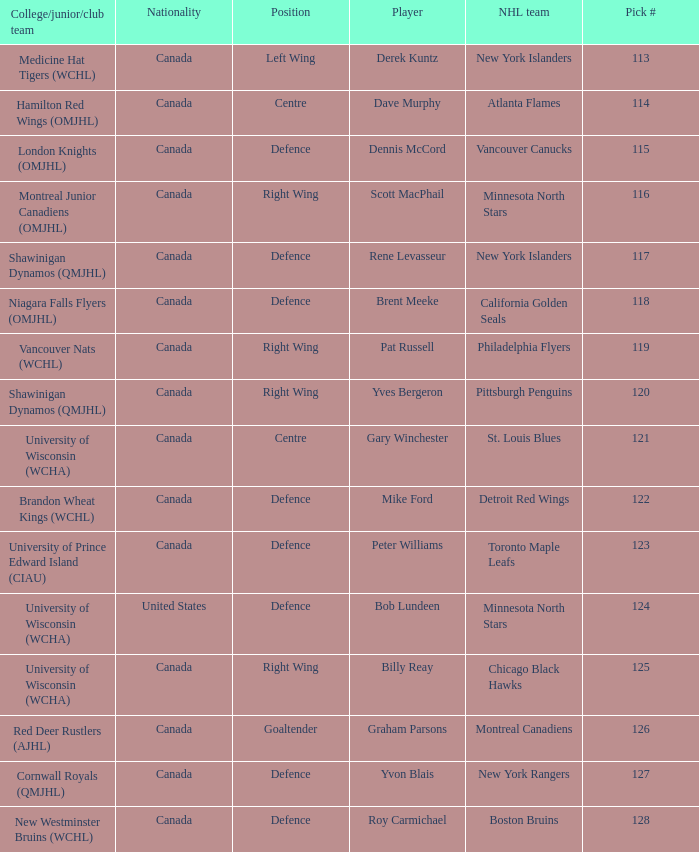Name the player for chicago black hawks Billy Reay. 